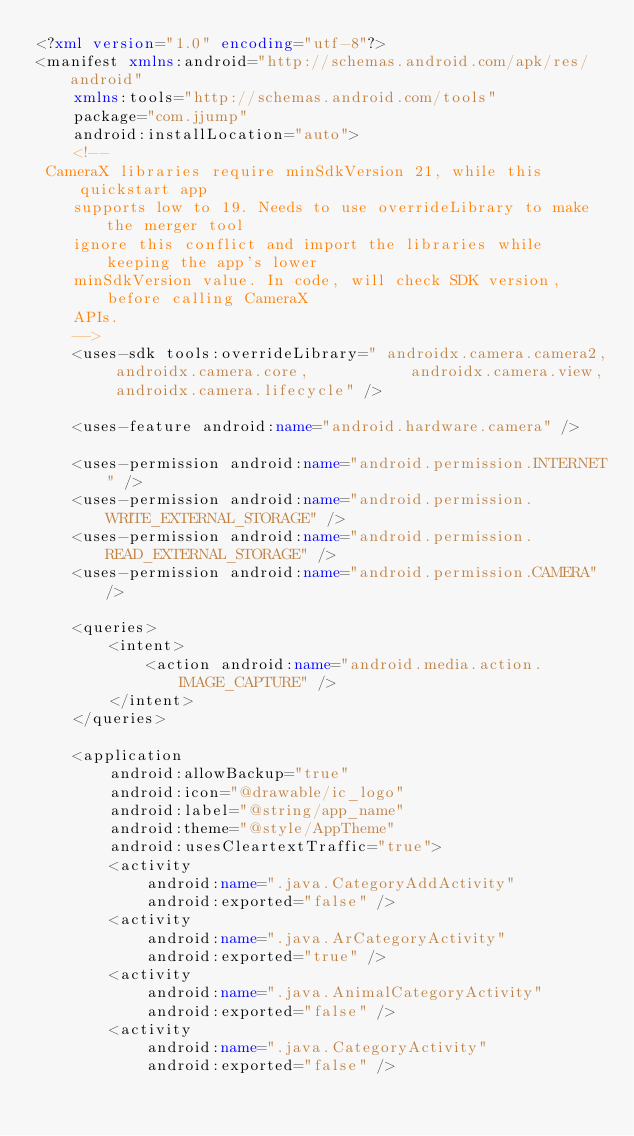Convert code to text. <code><loc_0><loc_0><loc_500><loc_500><_XML_><?xml version="1.0" encoding="utf-8"?>
<manifest xmlns:android="http://schemas.android.com/apk/res/android"
    xmlns:tools="http://schemas.android.com/tools"
    package="com.jjump"
    android:installLocation="auto">
    <!--
 CameraX libraries require minSdkVersion 21, while this quickstart app
    supports low to 19. Needs to use overrideLibrary to make the merger tool
    ignore this conflict and import the libraries while keeping the app's lower
    minSdkVersion value. In code, will check SDK version, before calling CameraX
    APIs.
    -->
    <uses-sdk tools:overrideLibrary=" androidx.camera.camera2, androidx.camera.core,           androidx.camera.view, androidx.camera.lifecycle" />

    <uses-feature android:name="android.hardware.camera" />

    <uses-permission android:name="android.permission.INTERNET" />
    <uses-permission android:name="android.permission.WRITE_EXTERNAL_STORAGE" />
    <uses-permission android:name="android.permission.READ_EXTERNAL_STORAGE" />
    <uses-permission android:name="android.permission.CAMERA" />

    <queries>
        <intent>
            <action android:name="android.media.action.IMAGE_CAPTURE" />
        </intent>
    </queries>

    <application
        android:allowBackup="true"
        android:icon="@drawable/ic_logo"
        android:label="@string/app_name"
        android:theme="@style/AppTheme"
        android:usesCleartextTraffic="true">
        <activity
            android:name=".java.CategoryAddActivity"
            android:exported="false" />
        <activity
            android:name=".java.ArCategoryActivity"
            android:exported="true" />
        <activity
            android:name=".java.AnimalCategoryActivity"
            android:exported="false" />
        <activity
            android:name=".java.CategoryActivity"
            android:exported="false" /></code> 